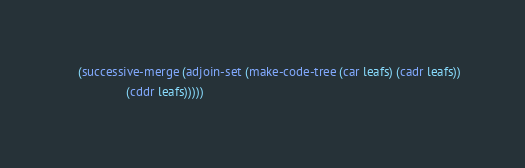<code> <loc_0><loc_0><loc_500><loc_500><_Scheme_>    (successive-merge (adjoin-set (make-code-tree (car leafs) (cadr leafs))
				  (cddr leafs)))))
</code> 